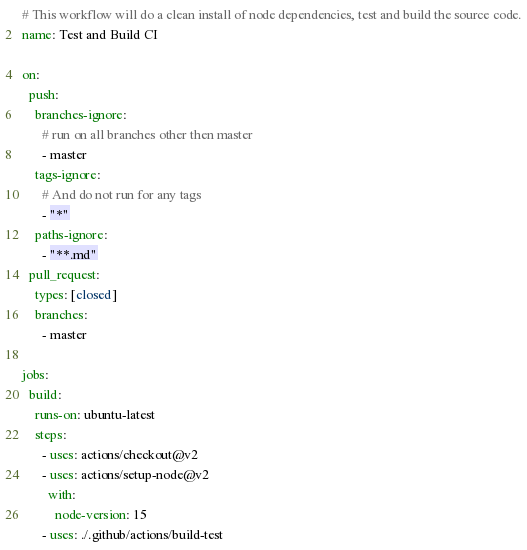Convert code to text. <code><loc_0><loc_0><loc_500><loc_500><_YAML_># This workflow will do a clean install of node dependencies, test and build the source code.
name: Test and Build CI

on:
  push:
    branches-ignore:
      # run on all branches other then master
      - master
    tags-ignore:
      # And do not run for any tags
      - "*"
    paths-ignore:
      - "**.md"
  pull_request:
    types: [closed]
    branches:
      - master

jobs:
  build:
    runs-on: ubuntu-latest
    steps:
      - uses: actions/checkout@v2
      - uses: actions/setup-node@v2
        with:
          node-version: 15
      - uses: ./.github/actions/build-test
</code> 